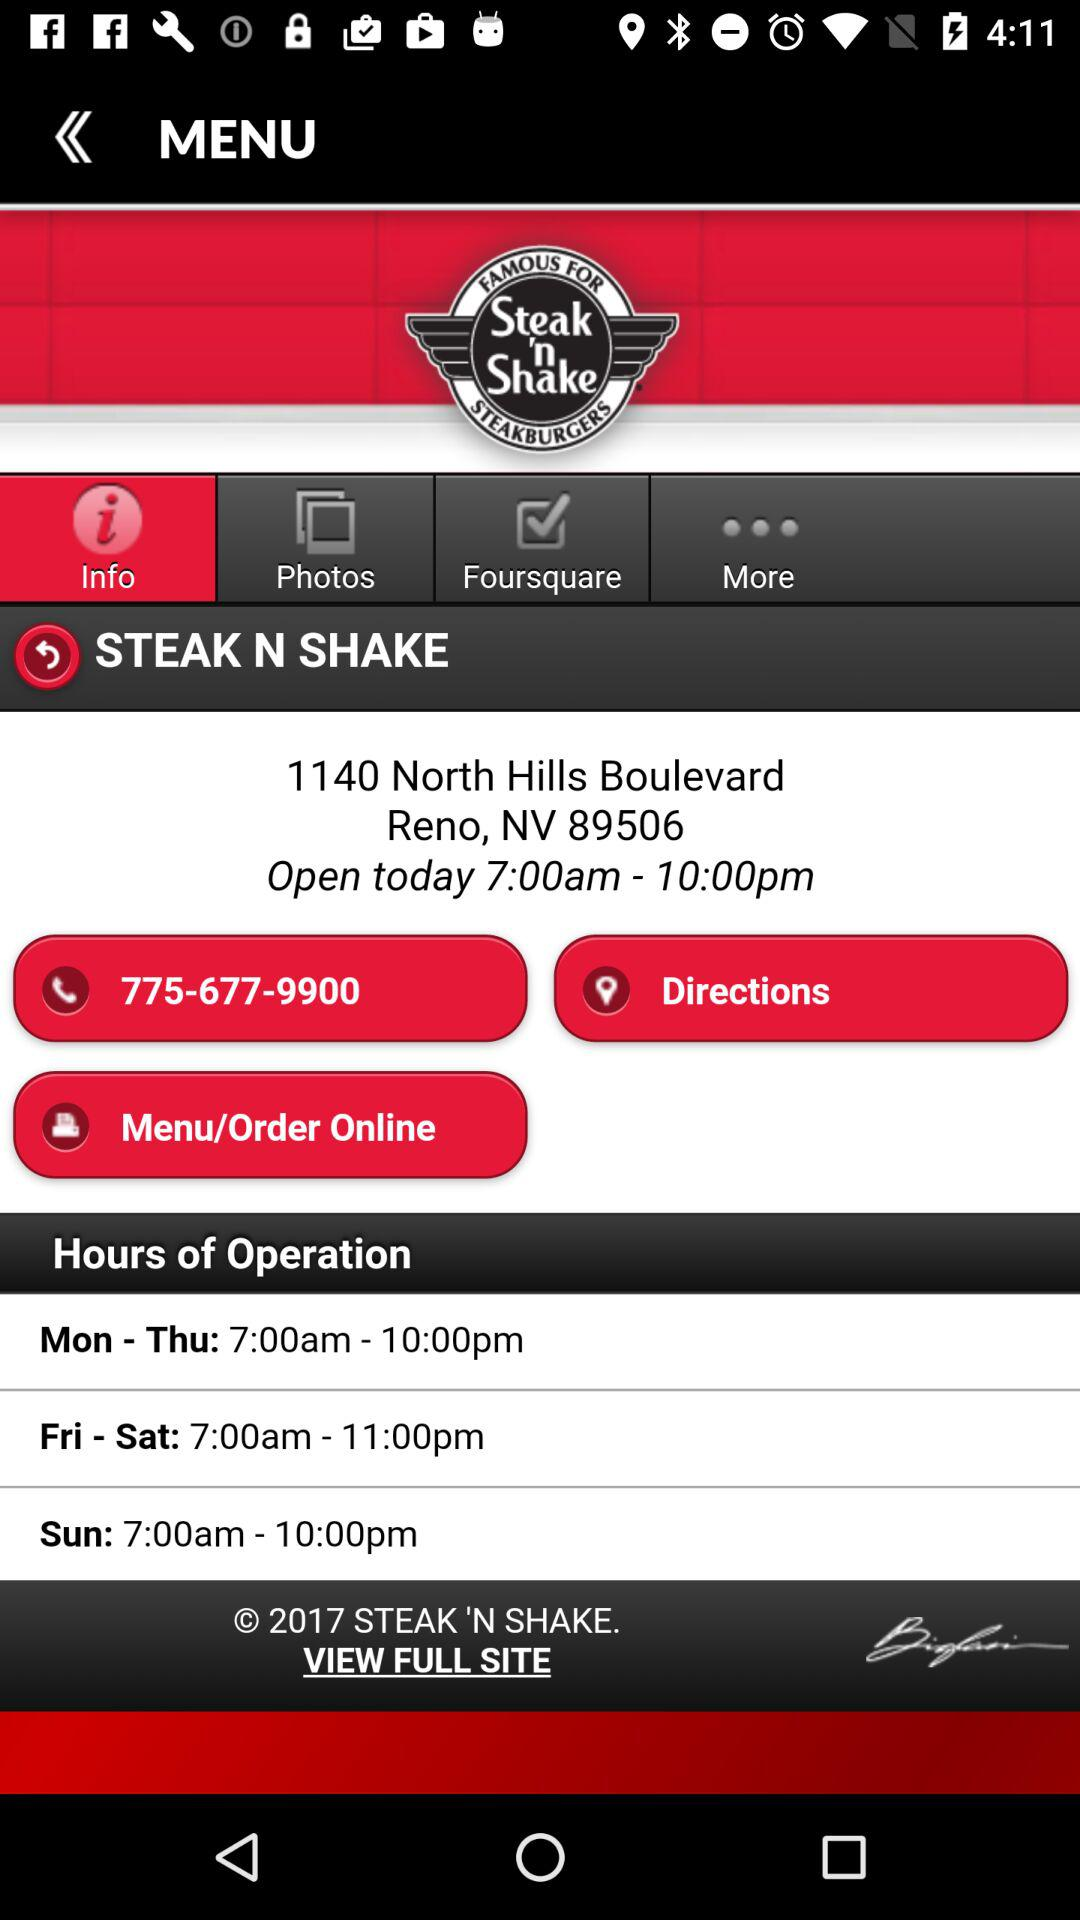What is the address of "STEAK N SHAKE"? The address of "STEAK N SHAKE" is 1140 North Hills Boulevard, Reno, NV 89506. 